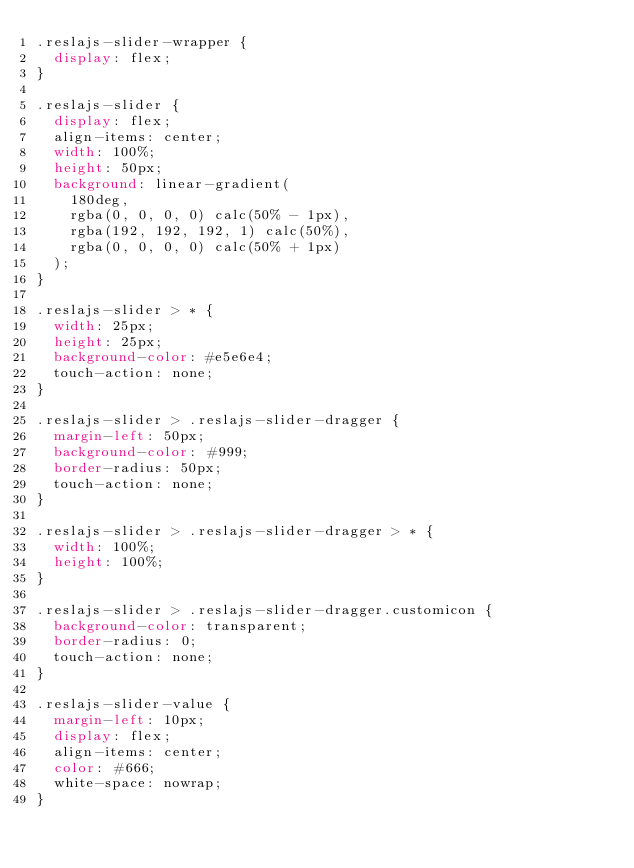Convert code to text. <code><loc_0><loc_0><loc_500><loc_500><_CSS_>.reslajs-slider-wrapper {
  display: flex;
}

.reslajs-slider {
  display: flex;
  align-items: center;
  width: 100%;
  height: 50px;
  background: linear-gradient(
    180deg,
    rgba(0, 0, 0, 0) calc(50% - 1px),
    rgba(192, 192, 192, 1) calc(50%),
    rgba(0, 0, 0, 0) calc(50% + 1px)
  );
}

.reslajs-slider > * {
  width: 25px;
  height: 25px;
  background-color: #e5e6e4;
  touch-action: none;
}

.reslajs-slider > .reslajs-slider-dragger {
  margin-left: 50px;
  background-color: #999;
  border-radius: 50px;
  touch-action: none;
}

.reslajs-slider > .reslajs-slider-dragger > * {
  width: 100%;
  height: 100%;
}

.reslajs-slider > .reslajs-slider-dragger.customicon {
  background-color: transparent;
  border-radius: 0;
  touch-action: none;
}

.reslajs-slider-value {
  margin-left: 10px;
  display: flex;
  align-items: center;
  color: #666;
  white-space: nowrap;
}
</code> 